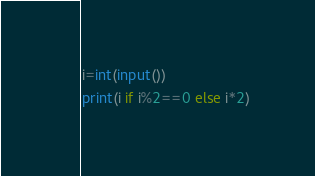<code> <loc_0><loc_0><loc_500><loc_500><_Python_>i=int(input())
print(i if i%2==0 else i*2)</code> 